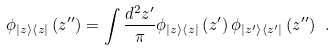<formula> <loc_0><loc_0><loc_500><loc_500>\phi _ { \left | z \right \rangle \left \langle z \right | } \left ( z ^ { \prime \prime } \right ) = \int \frac { d ^ { 2 } z ^ { \prime } } { \pi } \phi _ { \left | z \right \rangle \left \langle z \right | } \left ( z ^ { \prime } \right ) \phi _ { \left | z ^ { \prime } \right \rangle \left \langle z ^ { \prime } \right | } \left ( z ^ { \prime \prime } \right ) \ .</formula> 